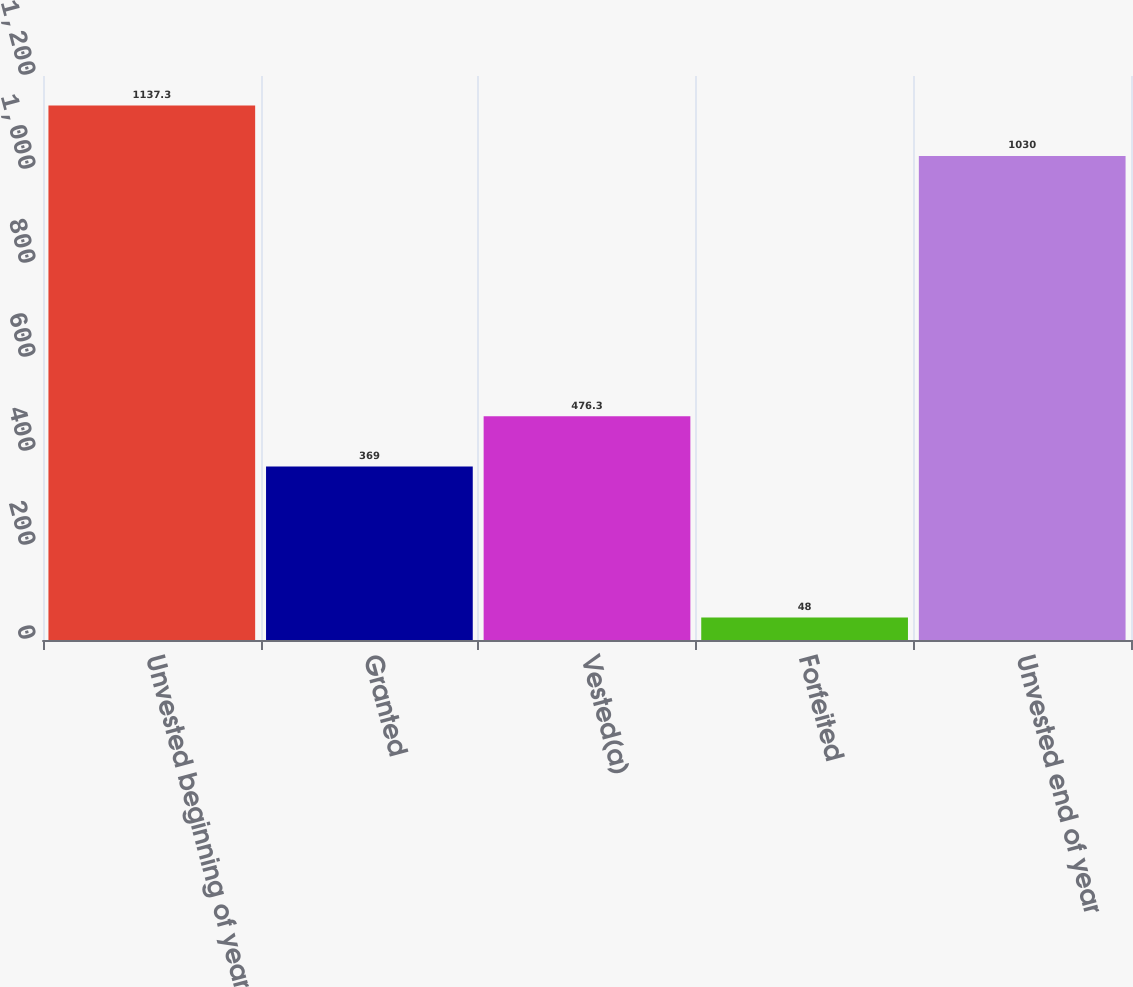<chart> <loc_0><loc_0><loc_500><loc_500><bar_chart><fcel>Unvested beginning of year<fcel>Granted<fcel>Vested(a)<fcel>Forfeited<fcel>Unvested end of year<nl><fcel>1137.3<fcel>369<fcel>476.3<fcel>48<fcel>1030<nl></chart> 